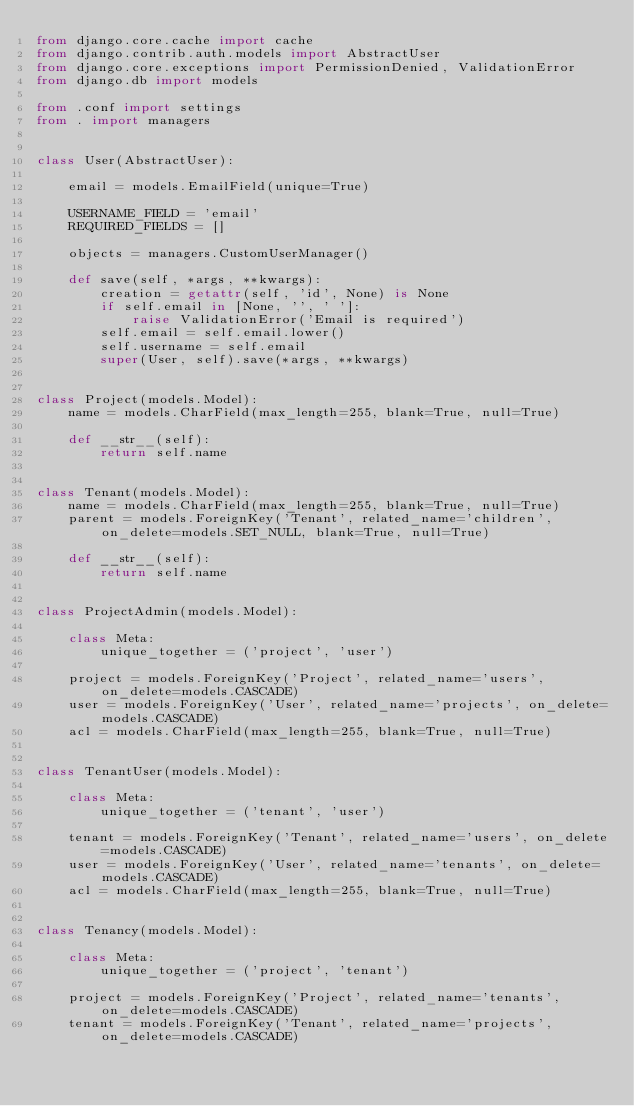Convert code to text. <code><loc_0><loc_0><loc_500><loc_500><_Python_>from django.core.cache import cache
from django.contrib.auth.models import AbstractUser
from django.core.exceptions import PermissionDenied, ValidationError
from django.db import models

from .conf import settings
from . import managers


class User(AbstractUser):

    email = models.EmailField(unique=True)

    USERNAME_FIELD = 'email'
    REQUIRED_FIELDS = []

    objects = managers.CustomUserManager()

    def save(self, *args, **kwargs):
        creation = getattr(self, 'id', None) is None
        if self.email in [None, '', ' ']:
            raise ValidationError('Email is required')
        self.email = self.email.lower()
        self.username = self.email
        super(User, self).save(*args, **kwargs)


class Project(models.Model):
    name = models.CharField(max_length=255, blank=True, null=True)

    def __str__(self):
        return self.name


class Tenant(models.Model):
    name = models.CharField(max_length=255, blank=True, null=True)
    parent = models.ForeignKey('Tenant', related_name='children', on_delete=models.SET_NULL, blank=True, null=True)

    def __str__(self):
        return self.name


class ProjectAdmin(models.Model):

    class Meta:
        unique_together = ('project', 'user')

    project = models.ForeignKey('Project', related_name='users', on_delete=models.CASCADE)
    user = models.ForeignKey('User', related_name='projects', on_delete=models.CASCADE)
    acl = models.CharField(max_length=255, blank=True, null=True)


class TenantUser(models.Model):

    class Meta:
        unique_together = ('tenant', 'user')

    tenant = models.ForeignKey('Tenant', related_name='users', on_delete=models.CASCADE)
    user = models.ForeignKey('User', related_name='tenants', on_delete=models.CASCADE)
    acl = models.CharField(max_length=255, blank=True, null=True)


class Tenancy(models.Model):

    class Meta:
        unique_together = ('project', 'tenant')

    project = models.ForeignKey('Project', related_name='tenants', on_delete=models.CASCADE)
    tenant = models.ForeignKey('Tenant', related_name='projects', on_delete=models.CASCADE)
</code> 